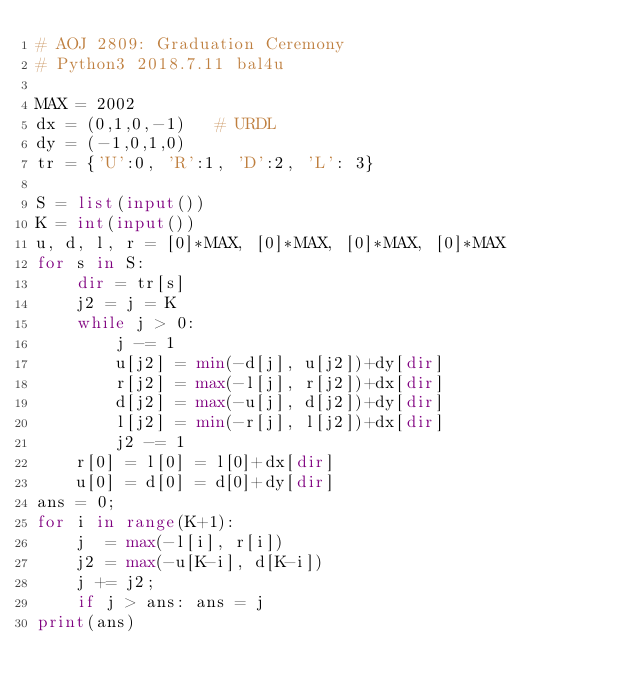Convert code to text. <code><loc_0><loc_0><loc_500><loc_500><_Python_># AOJ 2809: Graduation Ceremony
# Python3 2018.7.11 bal4u

MAX = 2002
dx = (0,1,0,-1)   # URDL
dy = (-1,0,1,0)
tr = {'U':0, 'R':1, 'D':2, 'L': 3}

S = list(input())
K = int(input())
u, d, l, r = [0]*MAX, [0]*MAX, [0]*MAX, [0]*MAX
for s in S:
	dir = tr[s]
	j2 = j = K
	while j > 0:
		j -= 1
		u[j2] = min(-d[j], u[j2])+dy[dir]
		r[j2] = max(-l[j], r[j2])+dx[dir]
		d[j2] = max(-u[j], d[j2])+dy[dir]
		l[j2] = min(-r[j], l[j2])+dx[dir]
		j2 -= 1
	r[0] = l[0] = l[0]+dx[dir]
	u[0] = d[0] = d[0]+dy[dir]
ans = 0;
for i in range(K+1):
	j  = max(-l[i], r[i])
	j2 = max(-u[K-i], d[K-i])
	j += j2;
	if j > ans: ans = j
print(ans)
</code> 